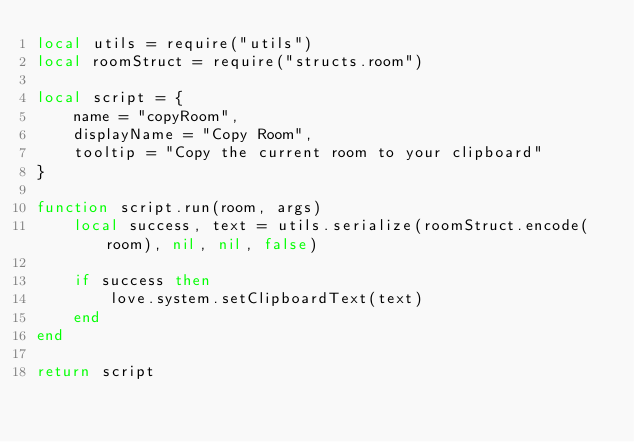Convert code to text. <code><loc_0><loc_0><loc_500><loc_500><_Lua_>local utils = require("utils")
local roomStruct = require("structs.room")

local script = {
    name = "copyRoom",
    displayName = "Copy Room",
    tooltip = "Copy the current room to your clipboard"
}

function script.run(room, args)
    local success, text = utils.serialize(roomStruct.encode(room), nil, nil, false)

    if success then
        love.system.setClipboardText(text)
    end
end

return script</code> 